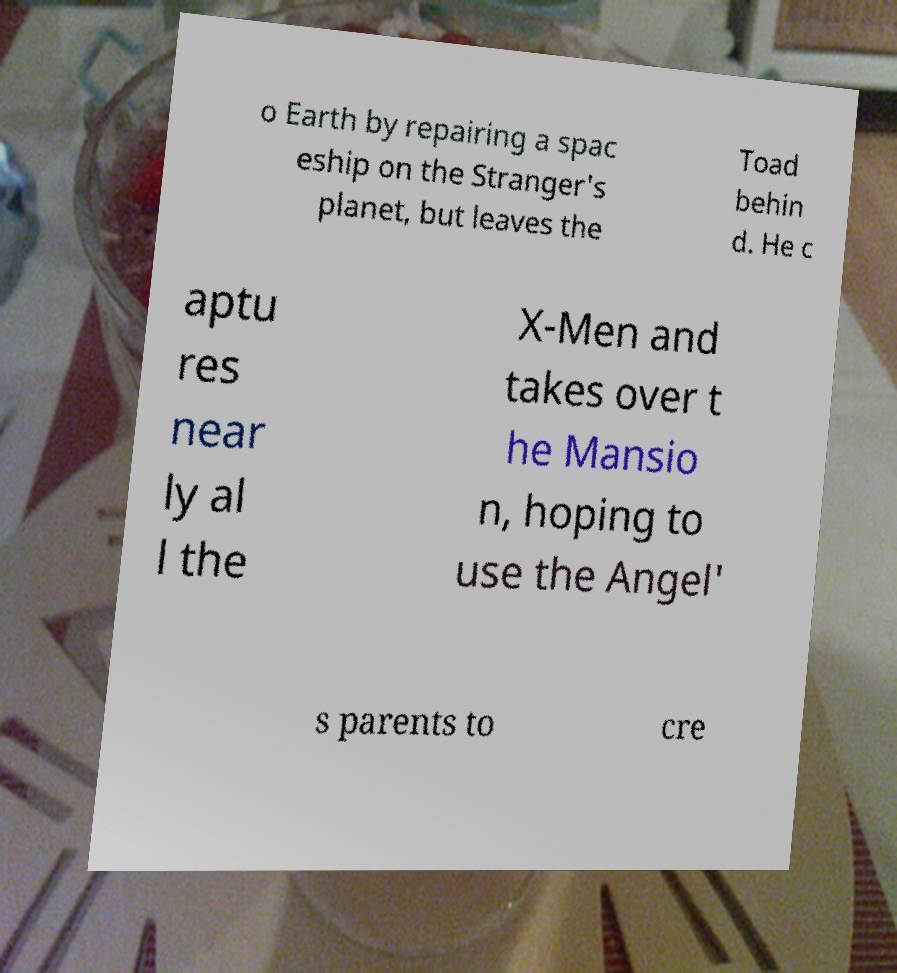Can you read and provide the text displayed in the image?This photo seems to have some interesting text. Can you extract and type it out for me? o Earth by repairing a spac eship on the Stranger's planet, but leaves the Toad behin d. He c aptu res near ly al l the X-Men and takes over t he Mansio n, hoping to use the Angel' s parents to cre 